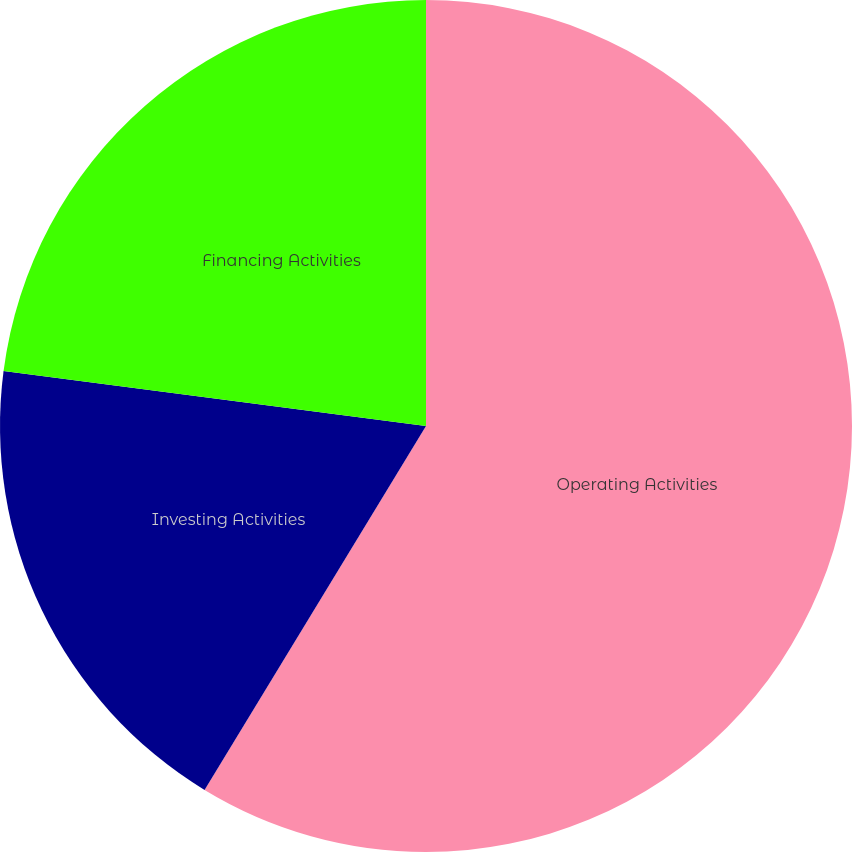Convert chart. <chart><loc_0><loc_0><loc_500><loc_500><pie_chart><fcel>Operating Activities<fcel>Investing Activities<fcel>Financing Activities<nl><fcel>58.7%<fcel>18.36%<fcel>22.94%<nl></chart> 